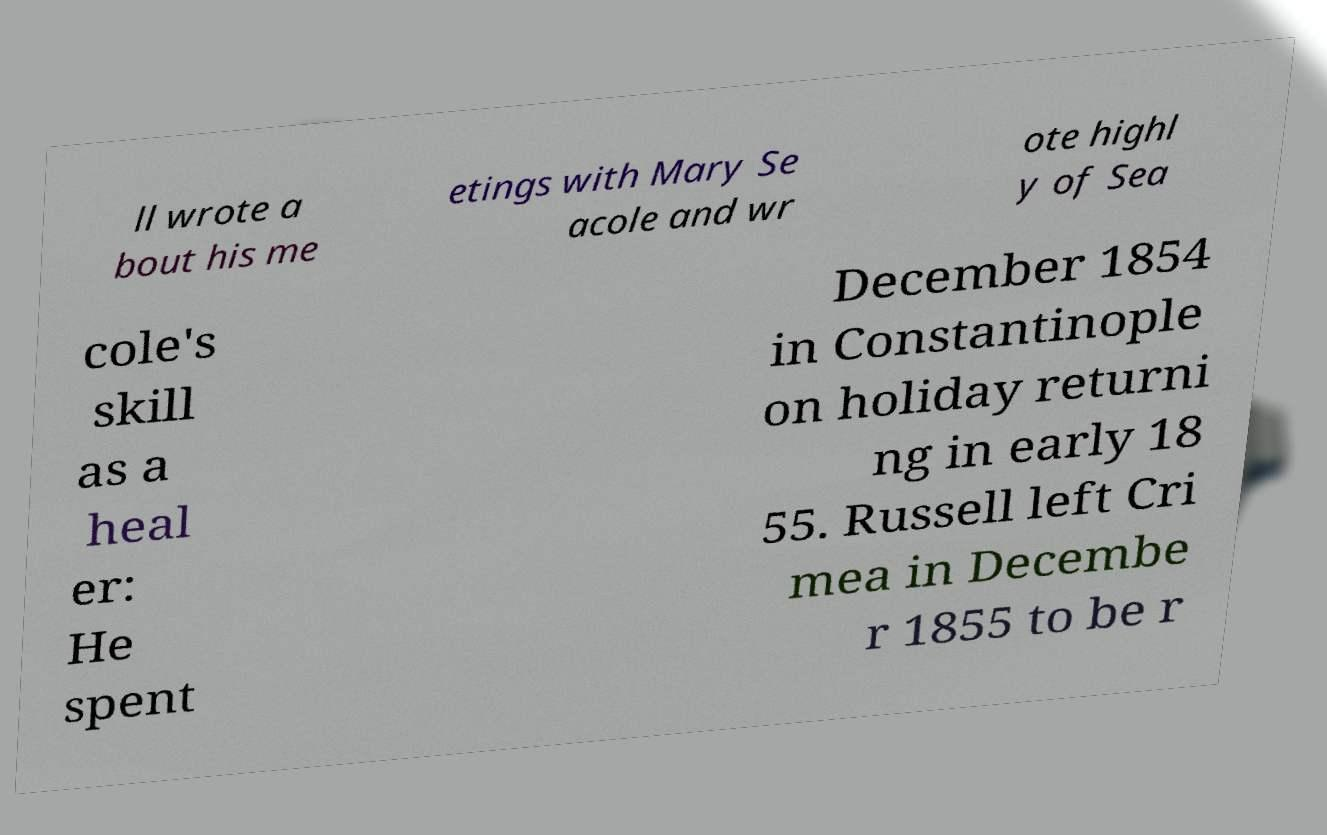For documentation purposes, I need the text within this image transcribed. Could you provide that? ll wrote a bout his me etings with Mary Se acole and wr ote highl y of Sea cole's skill as a heal er: He spent December 1854 in Constantinople on holiday returni ng in early 18 55. Russell left Cri mea in Decembe r 1855 to be r 